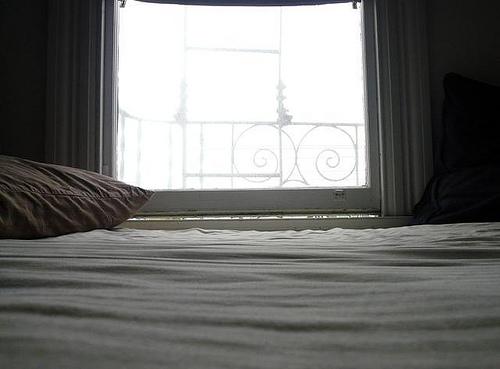Is there a pillow in the picture?
Answer briefly. Yes. What is outside the window?
Be succinct. Balcony. How many boxes of pizza are on the bed?
Short answer required. 0. Is the window open or closed?
Give a very brief answer. Closed. 